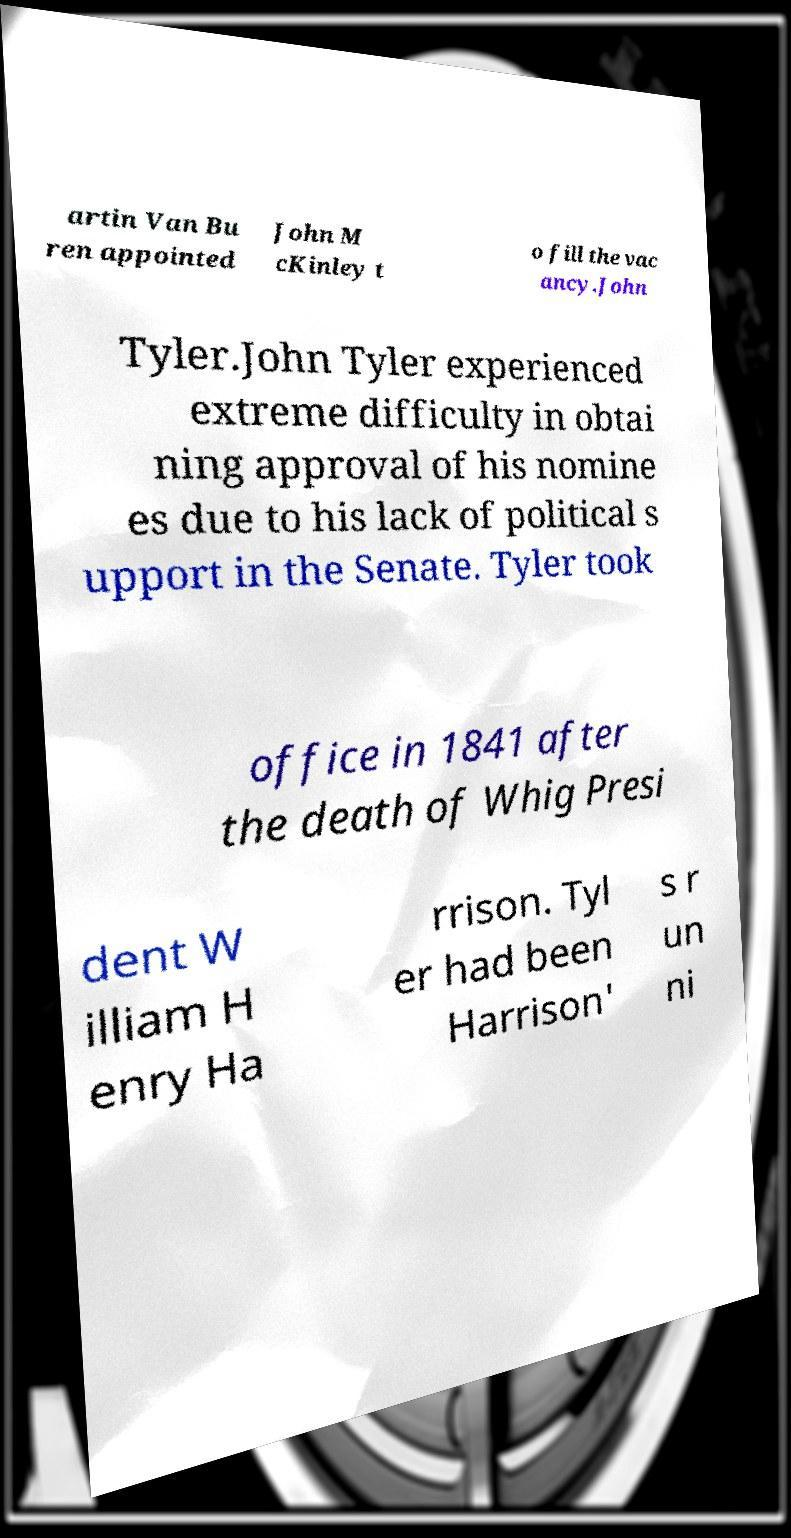I need the written content from this picture converted into text. Can you do that? artin Van Bu ren appointed John M cKinley t o fill the vac ancy.John Tyler.John Tyler experienced extreme difficulty in obtai ning approval of his nomine es due to his lack of political s upport in the Senate. Tyler took office in 1841 after the death of Whig Presi dent W illiam H enry Ha rrison. Tyl er had been Harrison' s r un ni 